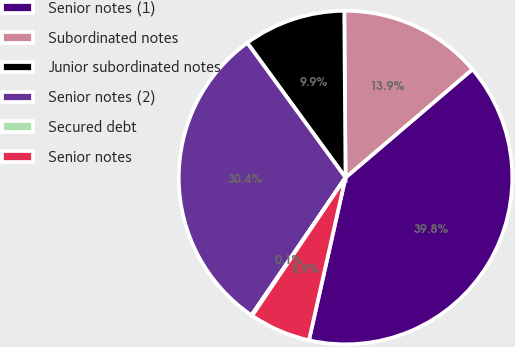Convert chart. <chart><loc_0><loc_0><loc_500><loc_500><pie_chart><fcel>Senior notes (1)<fcel>Subordinated notes<fcel>Junior subordinated notes<fcel>Senior notes (2)<fcel>Secured debt<fcel>Senior notes<nl><fcel>39.76%<fcel>13.88%<fcel>9.91%<fcel>30.43%<fcel>0.08%<fcel>5.94%<nl></chart> 